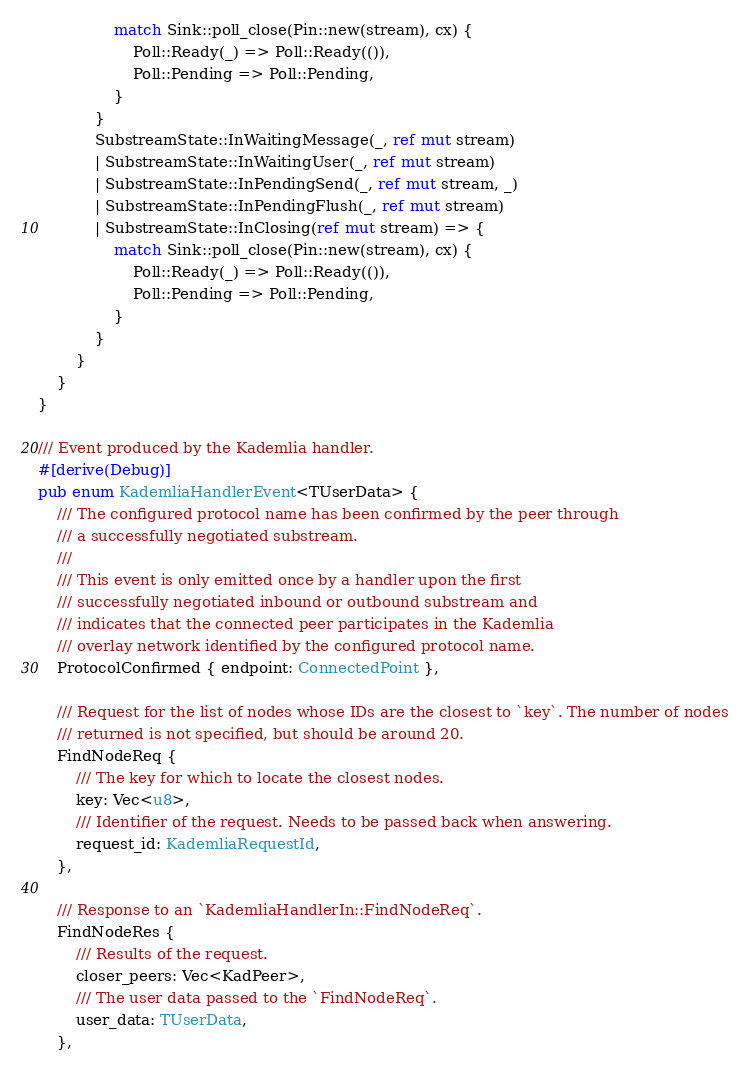<code> <loc_0><loc_0><loc_500><loc_500><_Rust_>                match Sink::poll_close(Pin::new(stream), cx) {
                    Poll::Ready(_) => Poll::Ready(()),
                    Poll::Pending => Poll::Pending,
                }
            }
            SubstreamState::InWaitingMessage(_, ref mut stream)
            | SubstreamState::InWaitingUser(_, ref mut stream)
            | SubstreamState::InPendingSend(_, ref mut stream, _)
            | SubstreamState::InPendingFlush(_, ref mut stream)
            | SubstreamState::InClosing(ref mut stream) => {
                match Sink::poll_close(Pin::new(stream), cx) {
                    Poll::Ready(_) => Poll::Ready(()),
                    Poll::Pending => Poll::Pending,
                }
            }
        }
    }
}

/// Event produced by the Kademlia handler.
#[derive(Debug)]
pub enum KademliaHandlerEvent<TUserData> {
    /// The configured protocol name has been confirmed by the peer through
    /// a successfully negotiated substream.
    ///
    /// This event is only emitted once by a handler upon the first
    /// successfully negotiated inbound or outbound substream and
    /// indicates that the connected peer participates in the Kademlia
    /// overlay network identified by the configured protocol name.
    ProtocolConfirmed { endpoint: ConnectedPoint },

    /// Request for the list of nodes whose IDs are the closest to `key`. The number of nodes
    /// returned is not specified, but should be around 20.
    FindNodeReq {
        /// The key for which to locate the closest nodes.
        key: Vec<u8>,
        /// Identifier of the request. Needs to be passed back when answering.
        request_id: KademliaRequestId,
    },

    /// Response to an `KademliaHandlerIn::FindNodeReq`.
    FindNodeRes {
        /// Results of the request.
        closer_peers: Vec<KadPeer>,
        /// The user data passed to the `FindNodeReq`.
        user_data: TUserData,
    },
</code> 